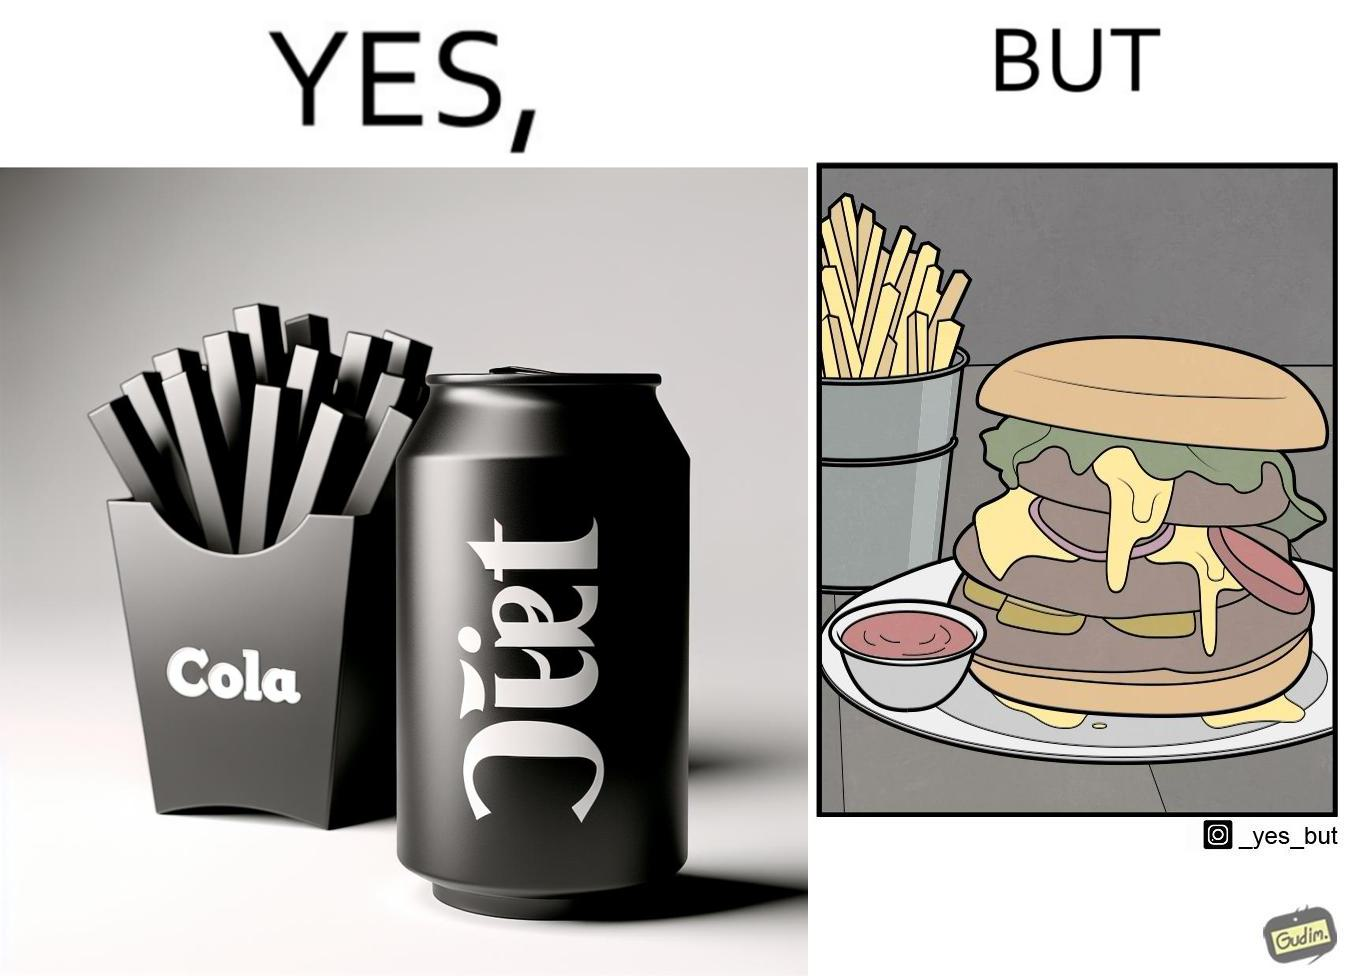What do you see in each half of this image? In the left part of the image: a cold drink can, named by diet cola, with french fries at the back In the right part of the image: a huge size burger with french fries 